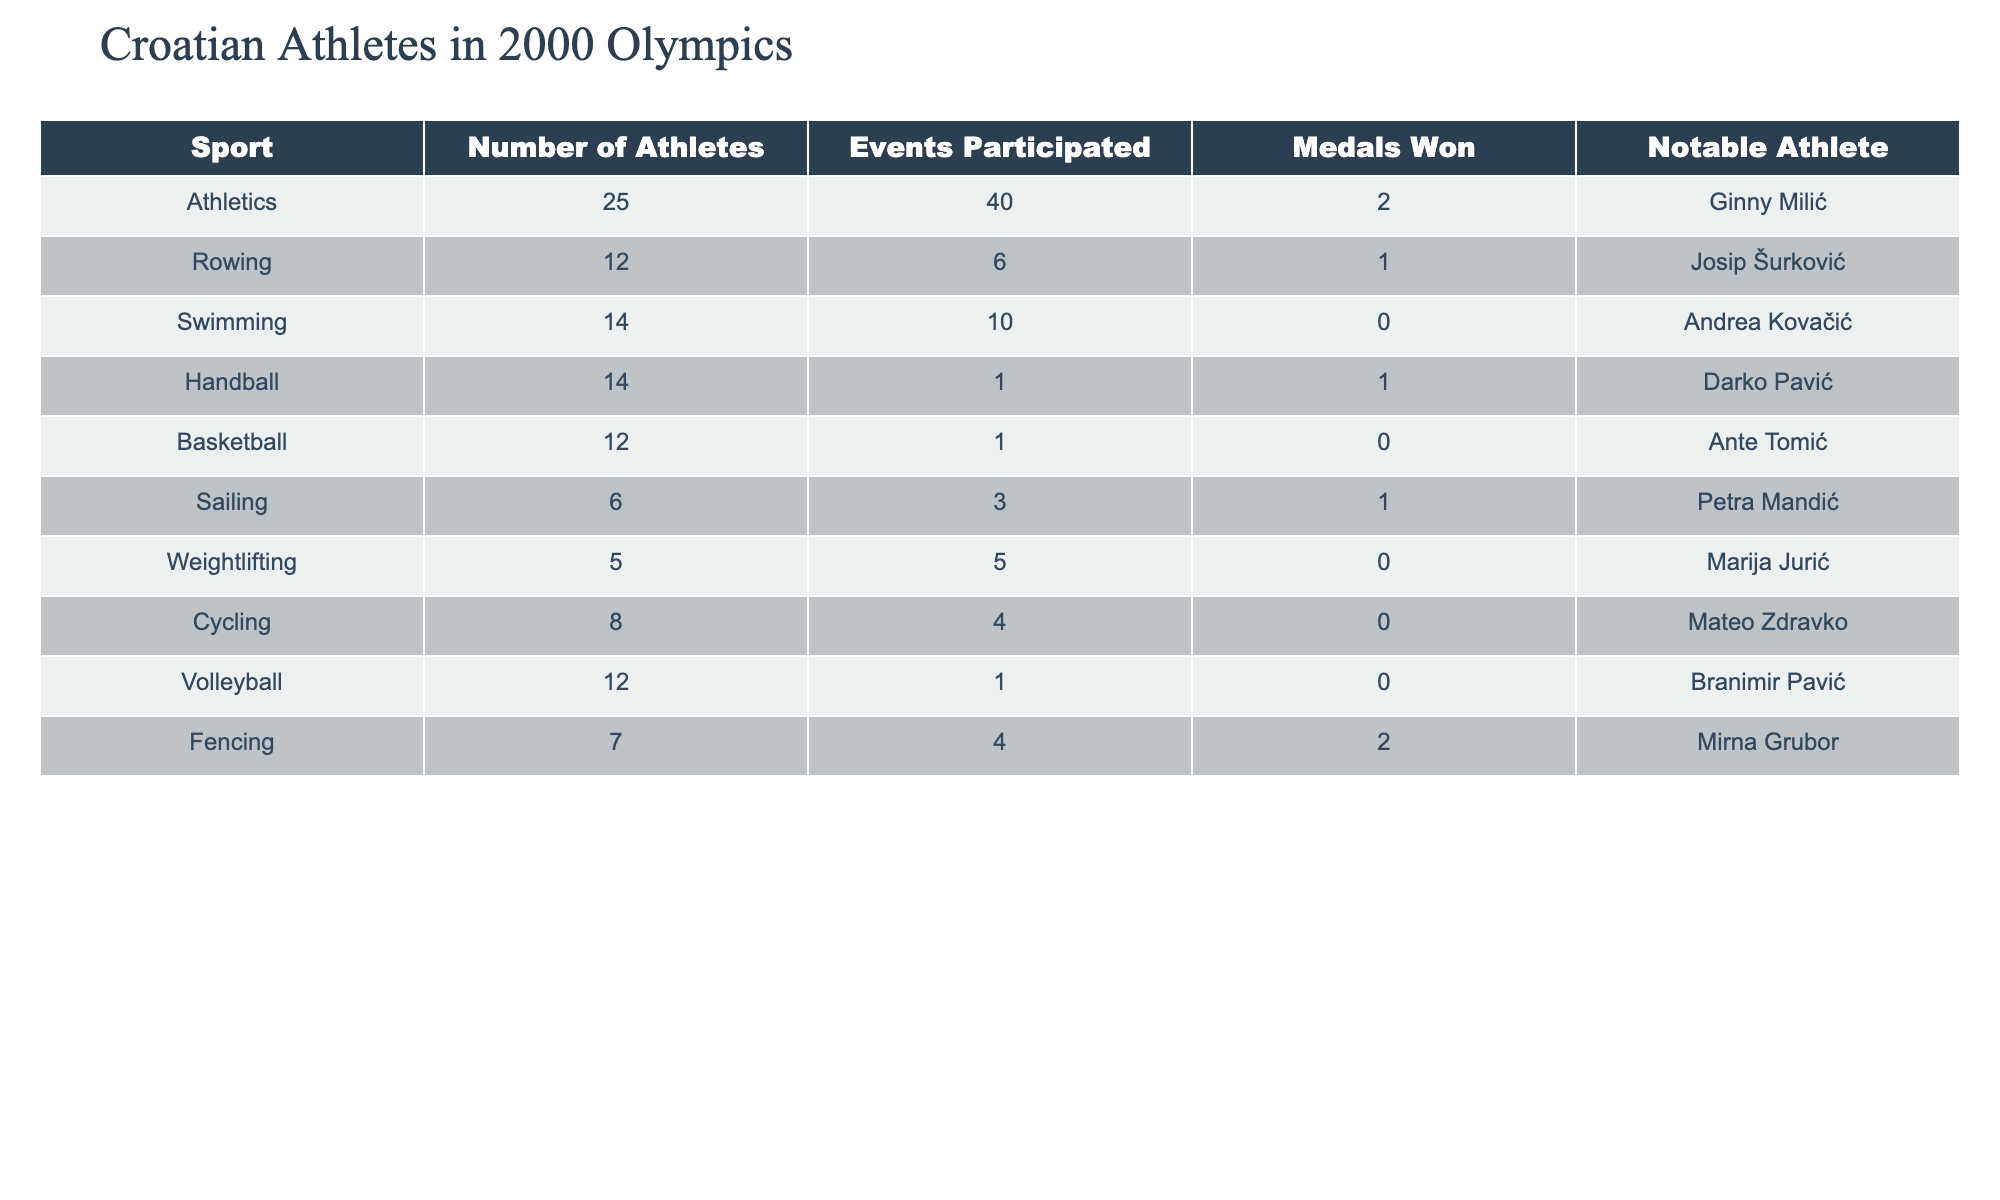What sport had the most athletes representing Croatia? The table shows the number of athletes for each sport. Athletics has the highest count with 25 athletes.
Answer: 25 How many medals did the Croatian athletes win in Swimming? According to the table, the medals won in Swimming is 0.
Answer: 0 Which sport had the highest number of events participated by Croatian athletes? The events participated column indicates that Athletics had 40 events participated, which is the highest among all sports.
Answer: 40 Did any athletes from Cycling win medals? The table specifies that the medals won in Cycling is 0, indicating no medals were won.
Answer: No What is the total number of medals won by Croatian athletes in the 2000 Olympics? To find the total, sum the medals won across all sports: 2 (Athletics) + 1 (Rowing) + 0 (Swimming) + 1 (Handball) + 0 (Basketball) + 1 (Sailing) + 0 (Weightlifting) + 0 (Cycling) + 0 (Volleyball) + 2 (Fencing) equals 7.
Answer: 7 Which sport had the notable athlete named Mirna Grubor? The table shows that Fencing lists Mirna Grubor as its notable athlete.
Answer: Fencing What was the average number of events participated by athletes in sports that won medals? The relevant sports that won medals are Athletics (40 events), Rowing (6 events), Handball (1 event), Sailing (3 events), and Fencing (4 events). Sum these events: 40 + 6 + 1 + 3 + 4 = 54. There are 5 sports, so the average is 54 / 5 = 10.8.
Answer: 10.8 How many sports had no medals won at all? The table indicates that Swimming, Basketball, Weightlifting, Cycling, and Volleyball did not win any medals. That totals to 5 sports.
Answer: 5 